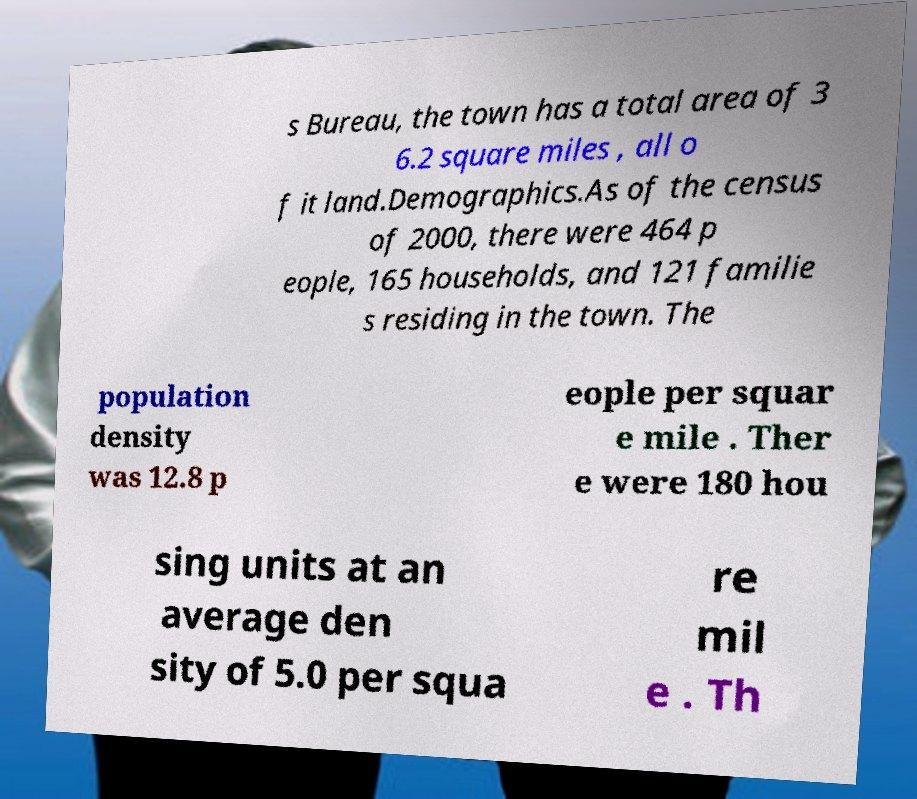There's text embedded in this image that I need extracted. Can you transcribe it verbatim? s Bureau, the town has a total area of 3 6.2 square miles , all o f it land.Demographics.As of the census of 2000, there were 464 p eople, 165 households, and 121 familie s residing in the town. The population density was 12.8 p eople per squar e mile . Ther e were 180 hou sing units at an average den sity of 5.0 per squa re mil e . Th 